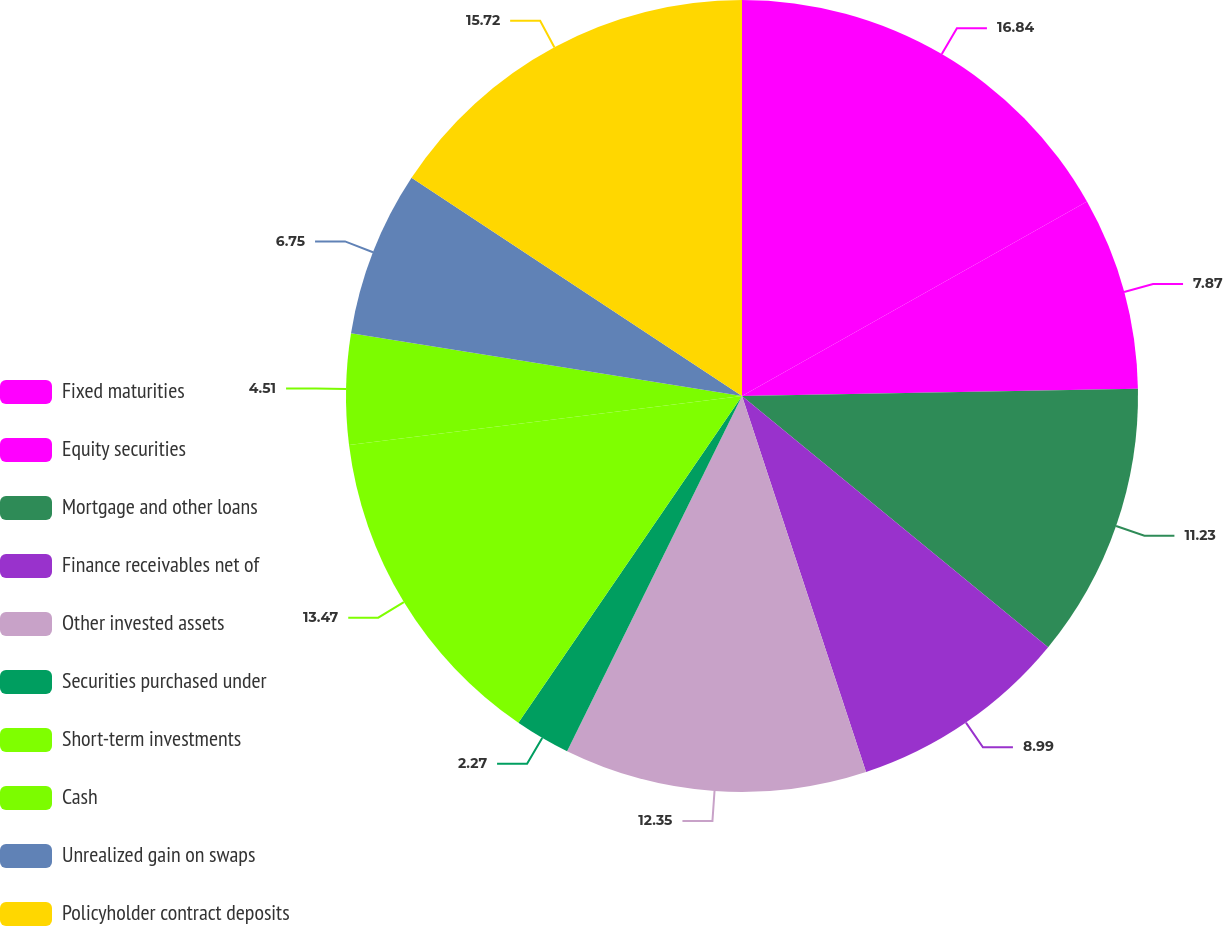<chart> <loc_0><loc_0><loc_500><loc_500><pie_chart><fcel>Fixed maturities<fcel>Equity securities<fcel>Mortgage and other loans<fcel>Finance receivables net of<fcel>Other invested assets<fcel>Securities purchased under<fcel>Short-term investments<fcel>Cash<fcel>Unrealized gain on swaps<fcel>Policyholder contract deposits<nl><fcel>16.83%<fcel>7.87%<fcel>11.23%<fcel>8.99%<fcel>12.35%<fcel>2.27%<fcel>13.47%<fcel>4.51%<fcel>6.75%<fcel>15.71%<nl></chart> 